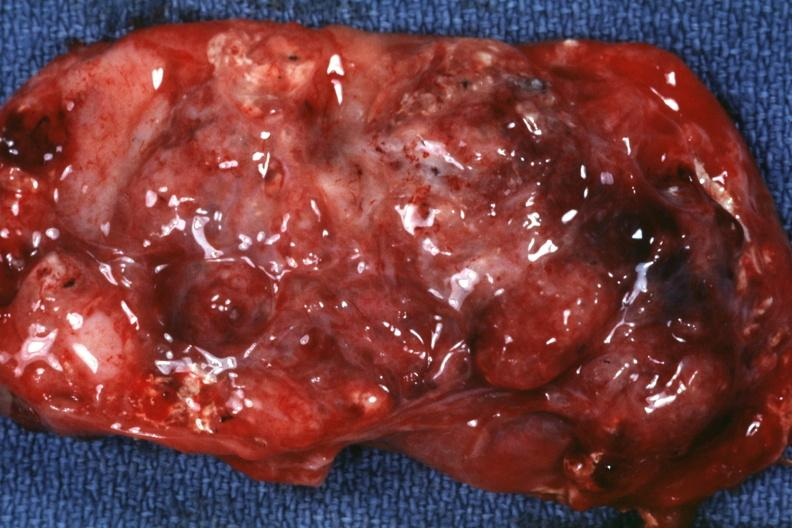s sacrococcygeal teratoma present?
Answer the question using a single word or phrase. Yes 